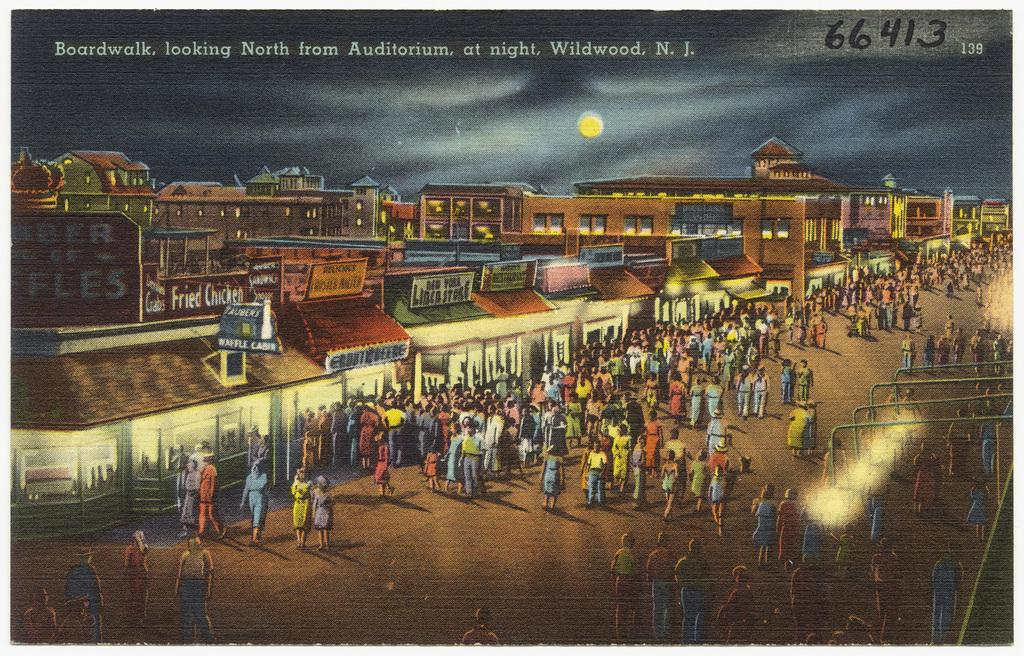<image>
Write a terse but informative summary of the picture. many people walking around and 66413 in the upper right 